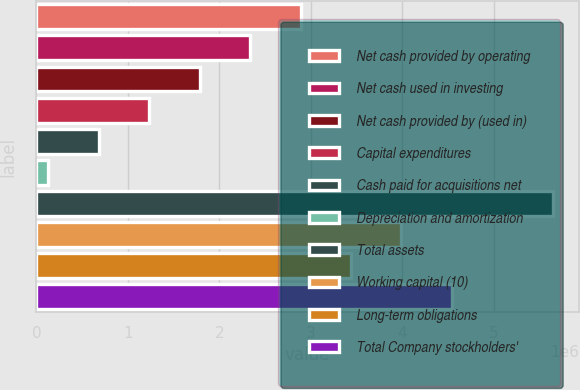Convert chart. <chart><loc_0><loc_0><loc_500><loc_500><bar_chart><fcel>Net cash provided by operating<fcel>Net cash used in investing<fcel>Net cash provided by (used in)<fcel>Capital expenditures<fcel>Cash paid for acquisitions net<fcel>Depreciation and amortization<fcel>Total assets<fcel>Working capital (10)<fcel>Long-term obligations<fcel>Total Company stockholders'<nl><fcel>2.88801e+06<fcel>2.33605e+06<fcel>1.78409e+06<fcel>1.23212e+06<fcel>680156<fcel>128192<fcel>5.64784e+06<fcel>3.99194e+06<fcel>3.43998e+06<fcel>4.54391e+06<nl></chart> 